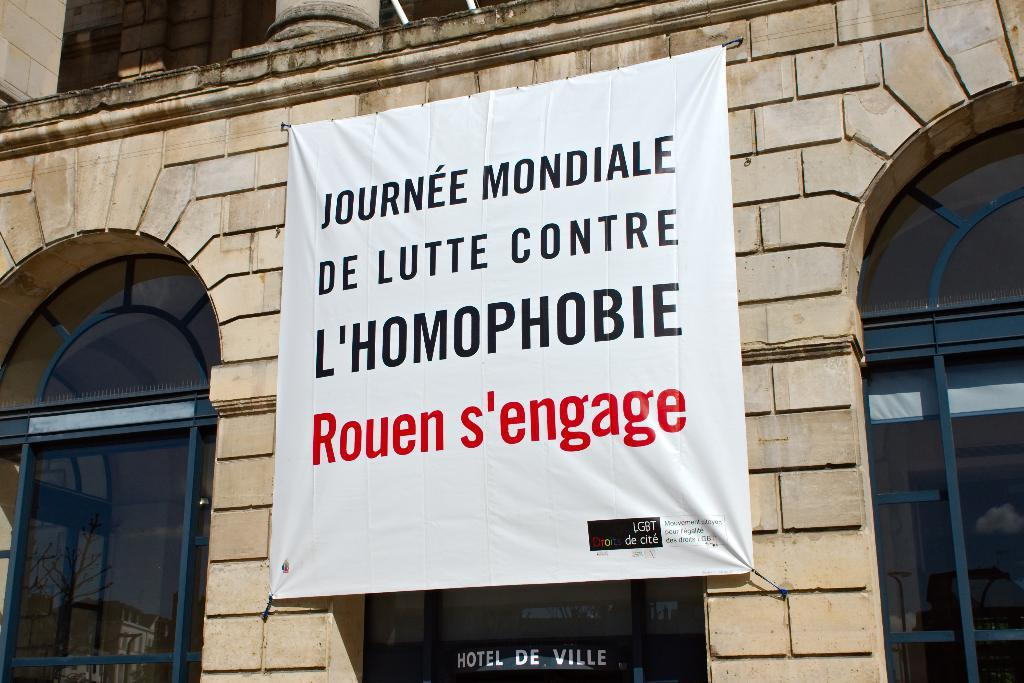What is the main structure in the picture? There is a building in the picture. What is placed in front of the building? There is a banner in front of the building. What feature can be seen on the building? The building has windows. How many pockets are visible on the building in the image? There are no pockets visible on the building in the image, as buildings do not have pockets. 